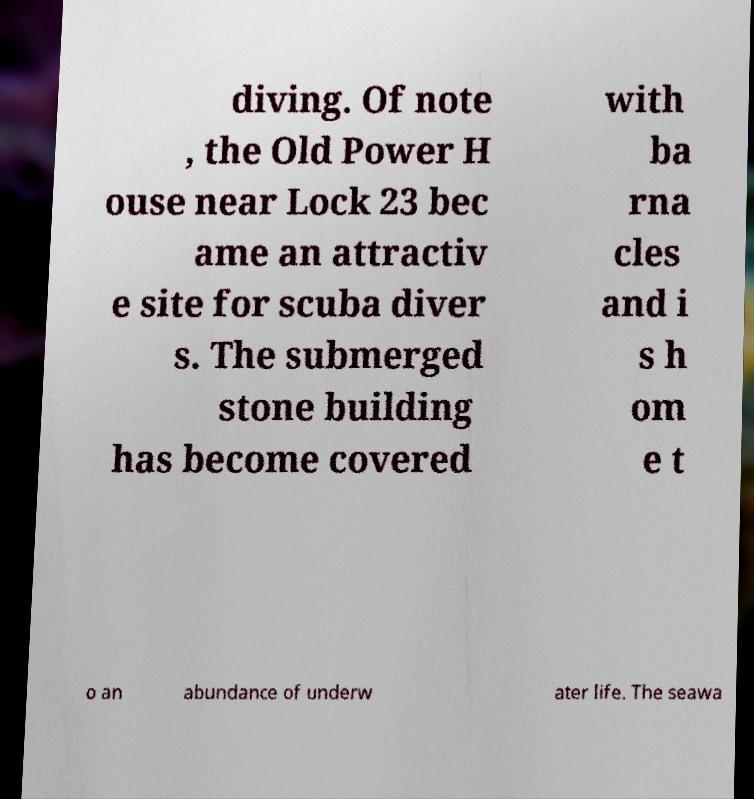Could you assist in decoding the text presented in this image and type it out clearly? diving. Of note , the Old Power H ouse near Lock 23 bec ame an attractiv e site for scuba diver s. The submerged stone building has become covered with ba rna cles and i s h om e t o an abundance of underw ater life. The seawa 